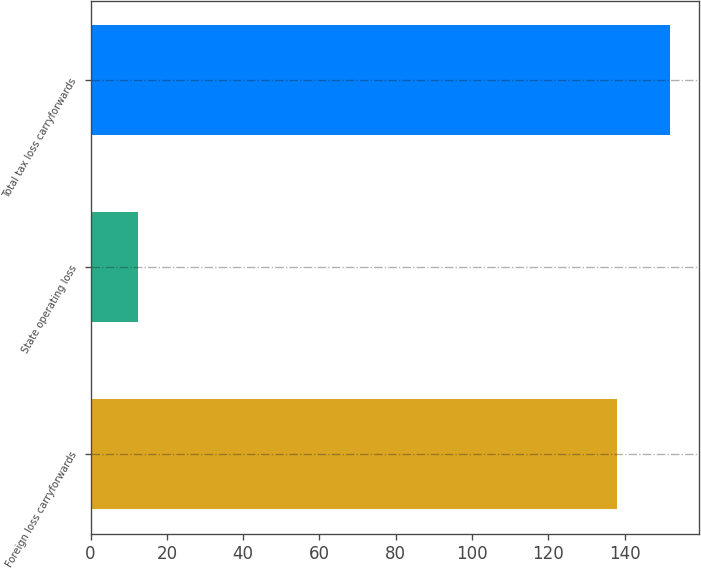<chart> <loc_0><loc_0><loc_500><loc_500><bar_chart><fcel>Foreign loss carryforwards<fcel>State operating loss<fcel>Total tax loss carryforwards<nl><fcel>138.1<fcel>12.5<fcel>151.91<nl></chart> 